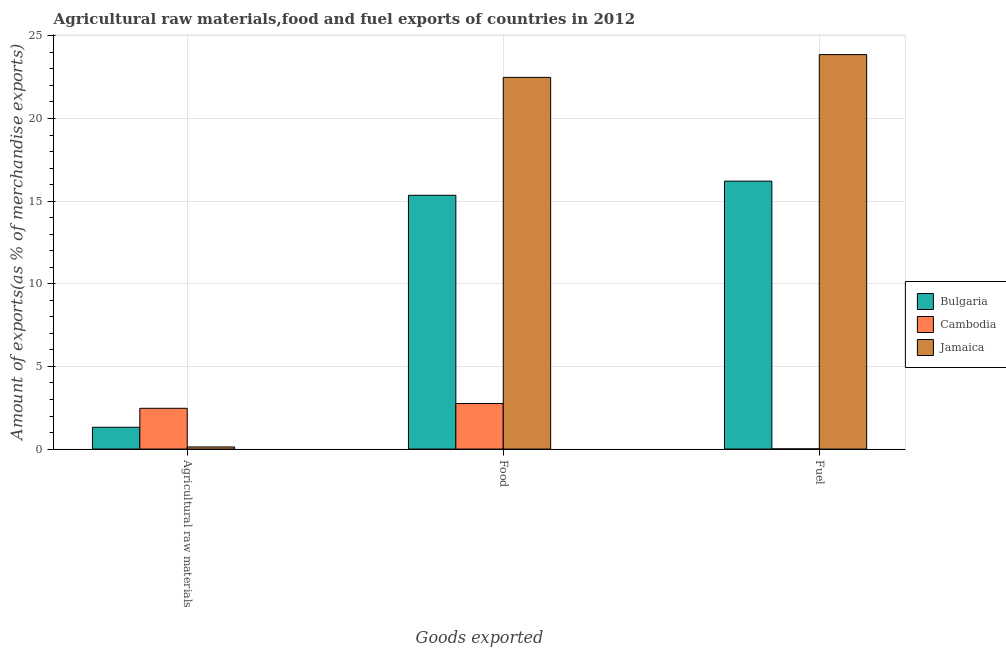How many different coloured bars are there?
Ensure brevity in your answer.  3. How many groups of bars are there?
Ensure brevity in your answer.  3. Are the number of bars on each tick of the X-axis equal?
Provide a short and direct response. Yes. How many bars are there on the 1st tick from the right?
Ensure brevity in your answer.  3. What is the label of the 2nd group of bars from the left?
Provide a succinct answer. Food. What is the percentage of raw materials exports in Cambodia?
Your answer should be very brief. 2.47. Across all countries, what is the maximum percentage of food exports?
Provide a succinct answer. 22.49. Across all countries, what is the minimum percentage of fuel exports?
Offer a very short reply. 0.01. In which country was the percentage of raw materials exports maximum?
Keep it short and to the point. Cambodia. In which country was the percentage of food exports minimum?
Your answer should be very brief. Cambodia. What is the total percentage of fuel exports in the graph?
Keep it short and to the point. 40.09. What is the difference between the percentage of raw materials exports in Jamaica and that in Cambodia?
Your answer should be very brief. -2.34. What is the difference between the percentage of raw materials exports in Bulgaria and the percentage of food exports in Jamaica?
Ensure brevity in your answer.  -21.17. What is the average percentage of fuel exports per country?
Give a very brief answer. 13.36. What is the difference between the percentage of fuel exports and percentage of raw materials exports in Bulgaria?
Offer a terse response. 14.89. What is the ratio of the percentage of food exports in Bulgaria to that in Cambodia?
Make the answer very short. 5.57. Is the percentage of food exports in Cambodia less than that in Bulgaria?
Your response must be concise. Yes. Is the difference between the percentage of fuel exports in Bulgaria and Jamaica greater than the difference between the percentage of food exports in Bulgaria and Jamaica?
Offer a terse response. No. What is the difference between the highest and the second highest percentage of fuel exports?
Your answer should be very brief. 7.66. What is the difference between the highest and the lowest percentage of raw materials exports?
Ensure brevity in your answer.  2.34. In how many countries, is the percentage of fuel exports greater than the average percentage of fuel exports taken over all countries?
Your answer should be compact. 2. What does the 3rd bar from the left in Food represents?
Make the answer very short. Jamaica. Is it the case that in every country, the sum of the percentage of raw materials exports and percentage of food exports is greater than the percentage of fuel exports?
Offer a very short reply. No. Are all the bars in the graph horizontal?
Provide a succinct answer. No. Does the graph contain grids?
Offer a very short reply. Yes. Where does the legend appear in the graph?
Keep it short and to the point. Center right. What is the title of the graph?
Your answer should be very brief. Agricultural raw materials,food and fuel exports of countries in 2012. What is the label or title of the X-axis?
Give a very brief answer. Goods exported. What is the label or title of the Y-axis?
Your answer should be compact. Amount of exports(as % of merchandise exports). What is the Amount of exports(as % of merchandise exports) in Bulgaria in Agricultural raw materials?
Keep it short and to the point. 1.32. What is the Amount of exports(as % of merchandise exports) of Cambodia in Agricultural raw materials?
Ensure brevity in your answer.  2.47. What is the Amount of exports(as % of merchandise exports) of Jamaica in Agricultural raw materials?
Give a very brief answer. 0.13. What is the Amount of exports(as % of merchandise exports) in Bulgaria in Food?
Your response must be concise. 15.35. What is the Amount of exports(as % of merchandise exports) in Cambodia in Food?
Offer a terse response. 2.76. What is the Amount of exports(as % of merchandise exports) of Jamaica in Food?
Offer a very short reply. 22.49. What is the Amount of exports(as % of merchandise exports) in Bulgaria in Fuel?
Offer a very short reply. 16.21. What is the Amount of exports(as % of merchandise exports) in Cambodia in Fuel?
Provide a succinct answer. 0.01. What is the Amount of exports(as % of merchandise exports) of Jamaica in Fuel?
Provide a short and direct response. 23.87. Across all Goods exported, what is the maximum Amount of exports(as % of merchandise exports) in Bulgaria?
Keep it short and to the point. 16.21. Across all Goods exported, what is the maximum Amount of exports(as % of merchandise exports) of Cambodia?
Your answer should be compact. 2.76. Across all Goods exported, what is the maximum Amount of exports(as % of merchandise exports) of Jamaica?
Offer a very short reply. 23.87. Across all Goods exported, what is the minimum Amount of exports(as % of merchandise exports) in Bulgaria?
Make the answer very short. 1.32. Across all Goods exported, what is the minimum Amount of exports(as % of merchandise exports) in Cambodia?
Ensure brevity in your answer.  0.01. Across all Goods exported, what is the minimum Amount of exports(as % of merchandise exports) in Jamaica?
Offer a terse response. 0.13. What is the total Amount of exports(as % of merchandise exports) in Bulgaria in the graph?
Make the answer very short. 32.88. What is the total Amount of exports(as % of merchandise exports) of Cambodia in the graph?
Make the answer very short. 5.23. What is the total Amount of exports(as % of merchandise exports) of Jamaica in the graph?
Keep it short and to the point. 46.48. What is the difference between the Amount of exports(as % of merchandise exports) in Bulgaria in Agricultural raw materials and that in Food?
Make the answer very short. -14.03. What is the difference between the Amount of exports(as % of merchandise exports) of Cambodia in Agricultural raw materials and that in Food?
Offer a terse response. -0.29. What is the difference between the Amount of exports(as % of merchandise exports) in Jamaica in Agricultural raw materials and that in Food?
Keep it short and to the point. -22.36. What is the difference between the Amount of exports(as % of merchandise exports) of Bulgaria in Agricultural raw materials and that in Fuel?
Make the answer very short. -14.89. What is the difference between the Amount of exports(as % of merchandise exports) in Cambodia in Agricultural raw materials and that in Fuel?
Make the answer very short. 2.46. What is the difference between the Amount of exports(as % of merchandise exports) of Jamaica in Agricultural raw materials and that in Fuel?
Your response must be concise. -23.74. What is the difference between the Amount of exports(as % of merchandise exports) in Bulgaria in Food and that in Fuel?
Keep it short and to the point. -0.86. What is the difference between the Amount of exports(as % of merchandise exports) in Cambodia in Food and that in Fuel?
Provide a short and direct response. 2.74. What is the difference between the Amount of exports(as % of merchandise exports) in Jamaica in Food and that in Fuel?
Give a very brief answer. -1.38. What is the difference between the Amount of exports(as % of merchandise exports) in Bulgaria in Agricultural raw materials and the Amount of exports(as % of merchandise exports) in Cambodia in Food?
Your answer should be compact. -1.44. What is the difference between the Amount of exports(as % of merchandise exports) of Bulgaria in Agricultural raw materials and the Amount of exports(as % of merchandise exports) of Jamaica in Food?
Offer a terse response. -21.17. What is the difference between the Amount of exports(as % of merchandise exports) of Cambodia in Agricultural raw materials and the Amount of exports(as % of merchandise exports) of Jamaica in Food?
Offer a terse response. -20.02. What is the difference between the Amount of exports(as % of merchandise exports) of Bulgaria in Agricultural raw materials and the Amount of exports(as % of merchandise exports) of Cambodia in Fuel?
Make the answer very short. 1.31. What is the difference between the Amount of exports(as % of merchandise exports) in Bulgaria in Agricultural raw materials and the Amount of exports(as % of merchandise exports) in Jamaica in Fuel?
Your answer should be compact. -22.55. What is the difference between the Amount of exports(as % of merchandise exports) of Cambodia in Agricultural raw materials and the Amount of exports(as % of merchandise exports) of Jamaica in Fuel?
Your answer should be compact. -21.4. What is the difference between the Amount of exports(as % of merchandise exports) in Bulgaria in Food and the Amount of exports(as % of merchandise exports) in Cambodia in Fuel?
Your response must be concise. 15.34. What is the difference between the Amount of exports(as % of merchandise exports) of Bulgaria in Food and the Amount of exports(as % of merchandise exports) of Jamaica in Fuel?
Keep it short and to the point. -8.51. What is the difference between the Amount of exports(as % of merchandise exports) in Cambodia in Food and the Amount of exports(as % of merchandise exports) in Jamaica in Fuel?
Give a very brief answer. -21.11. What is the average Amount of exports(as % of merchandise exports) in Bulgaria per Goods exported?
Your response must be concise. 10.96. What is the average Amount of exports(as % of merchandise exports) in Cambodia per Goods exported?
Provide a succinct answer. 1.74. What is the average Amount of exports(as % of merchandise exports) in Jamaica per Goods exported?
Keep it short and to the point. 15.49. What is the difference between the Amount of exports(as % of merchandise exports) of Bulgaria and Amount of exports(as % of merchandise exports) of Cambodia in Agricultural raw materials?
Your answer should be very brief. -1.15. What is the difference between the Amount of exports(as % of merchandise exports) in Bulgaria and Amount of exports(as % of merchandise exports) in Jamaica in Agricultural raw materials?
Ensure brevity in your answer.  1.19. What is the difference between the Amount of exports(as % of merchandise exports) of Cambodia and Amount of exports(as % of merchandise exports) of Jamaica in Agricultural raw materials?
Keep it short and to the point. 2.34. What is the difference between the Amount of exports(as % of merchandise exports) of Bulgaria and Amount of exports(as % of merchandise exports) of Cambodia in Food?
Your answer should be compact. 12.6. What is the difference between the Amount of exports(as % of merchandise exports) of Bulgaria and Amount of exports(as % of merchandise exports) of Jamaica in Food?
Keep it short and to the point. -7.13. What is the difference between the Amount of exports(as % of merchandise exports) of Cambodia and Amount of exports(as % of merchandise exports) of Jamaica in Food?
Ensure brevity in your answer.  -19.73. What is the difference between the Amount of exports(as % of merchandise exports) in Bulgaria and Amount of exports(as % of merchandise exports) in Cambodia in Fuel?
Ensure brevity in your answer.  16.2. What is the difference between the Amount of exports(as % of merchandise exports) of Bulgaria and Amount of exports(as % of merchandise exports) of Jamaica in Fuel?
Make the answer very short. -7.66. What is the difference between the Amount of exports(as % of merchandise exports) in Cambodia and Amount of exports(as % of merchandise exports) in Jamaica in Fuel?
Keep it short and to the point. -23.85. What is the ratio of the Amount of exports(as % of merchandise exports) in Bulgaria in Agricultural raw materials to that in Food?
Offer a very short reply. 0.09. What is the ratio of the Amount of exports(as % of merchandise exports) in Cambodia in Agricultural raw materials to that in Food?
Your answer should be very brief. 0.9. What is the ratio of the Amount of exports(as % of merchandise exports) in Jamaica in Agricultural raw materials to that in Food?
Your answer should be very brief. 0.01. What is the ratio of the Amount of exports(as % of merchandise exports) of Bulgaria in Agricultural raw materials to that in Fuel?
Make the answer very short. 0.08. What is the ratio of the Amount of exports(as % of merchandise exports) in Cambodia in Agricultural raw materials to that in Fuel?
Your answer should be very brief. 226.11. What is the ratio of the Amount of exports(as % of merchandise exports) in Jamaica in Agricultural raw materials to that in Fuel?
Offer a terse response. 0.01. What is the ratio of the Amount of exports(as % of merchandise exports) in Bulgaria in Food to that in Fuel?
Your answer should be compact. 0.95. What is the ratio of the Amount of exports(as % of merchandise exports) in Cambodia in Food to that in Fuel?
Your answer should be compact. 252.61. What is the ratio of the Amount of exports(as % of merchandise exports) in Jamaica in Food to that in Fuel?
Your response must be concise. 0.94. What is the difference between the highest and the second highest Amount of exports(as % of merchandise exports) in Bulgaria?
Your response must be concise. 0.86. What is the difference between the highest and the second highest Amount of exports(as % of merchandise exports) of Cambodia?
Provide a succinct answer. 0.29. What is the difference between the highest and the second highest Amount of exports(as % of merchandise exports) in Jamaica?
Give a very brief answer. 1.38. What is the difference between the highest and the lowest Amount of exports(as % of merchandise exports) in Bulgaria?
Give a very brief answer. 14.89. What is the difference between the highest and the lowest Amount of exports(as % of merchandise exports) of Cambodia?
Your answer should be very brief. 2.74. What is the difference between the highest and the lowest Amount of exports(as % of merchandise exports) of Jamaica?
Your answer should be compact. 23.74. 